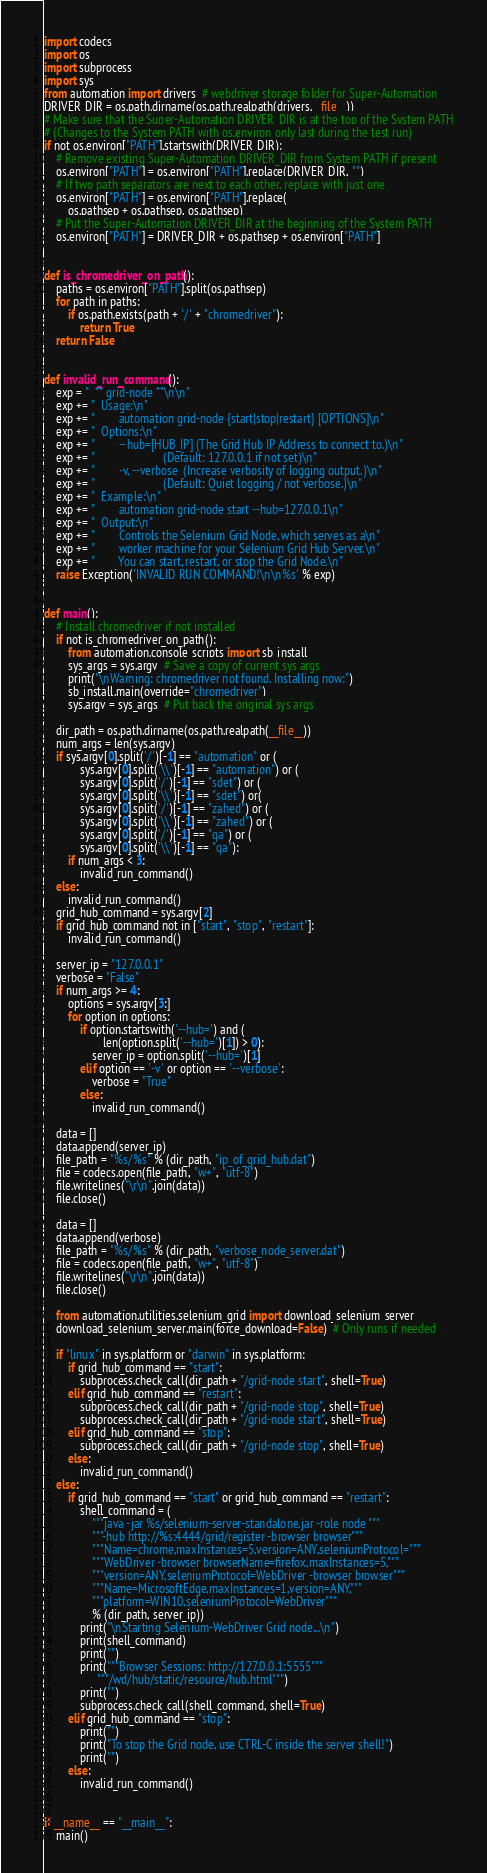Convert code to text. <code><loc_0><loc_0><loc_500><loc_500><_Python_>import codecs
import os
import subprocess
import sys
from automation import drivers  # webdriver storage folder for Super-Automation
DRIVER_DIR = os.path.dirname(os.path.realpath(drivers.__file__))
# Make sure that the Super-Automation DRIVER_DIR is at the top of the System PATH
# (Changes to the System PATH with os.environ only last during the test run)
if not os.environ["PATH"].startswith(DRIVER_DIR):
    # Remove existing Super-Automation DRIVER_DIR from System PATH if present
    os.environ["PATH"] = os.environ["PATH"].replace(DRIVER_DIR, "")
    # If two path separators are next to each other, replace with just one
    os.environ["PATH"] = os.environ["PATH"].replace(
        os.pathsep + os.pathsep, os.pathsep)
    # Put the Super-Automation DRIVER_DIR at the beginning of the System PATH
    os.environ["PATH"] = DRIVER_DIR + os.pathsep + os.environ["PATH"]


def is_chromedriver_on_path():
    paths = os.environ["PATH"].split(os.pathsep)
    for path in paths:
        if os.path.exists(path + '/' + "chromedriver"):
            return True
    return False


def invalid_run_command():
    exp = "  ** grid-node **\n\n"
    exp += "  Usage:\n"
    exp += "        automation grid-node {start|stop|restart} [OPTIONS]\n"
    exp += "  Options:\n"
    exp += "        --hub=[HUB_IP] (The Grid Hub IP Address to connect to.)\n"
    exp += "                       (Default: 127.0.0.1 if not set)\n"
    exp += "        -v, --verbose  (Increase verbosity of logging output.)\n"
    exp += "                       (Default: Quiet logging / not verbose.)\n"
    exp += "  Example:\n"
    exp += "        automation grid-node start --hub=127.0.0.1\n"
    exp += "  Output:\n"
    exp += "        Controls the Selenium Grid Node, which serves as a\n"
    exp += "        worker machine for your Selenium Grid Hub Server.\n"
    exp += "        You can start, restart, or stop the Grid Node.\n"
    raise Exception('INVALID RUN COMMAND!\n\n%s' % exp)


def main():
    # Install chromedriver if not installed
    if not is_chromedriver_on_path():
        from automation.console_scripts import sb_install
        sys_args = sys.argv  # Save a copy of current sys args
        print("\nWarning: chromedriver not found. Installing now:")
        sb_install.main(override="chromedriver")
        sys.argv = sys_args  # Put back the original sys args

    dir_path = os.path.dirname(os.path.realpath(__file__))
    num_args = len(sys.argv)
    if sys.argv[0].split('/')[-1] == "automation" or (
            sys.argv[0].split('\\')[-1] == "automation") or (
            sys.argv[0].split('/')[-1] == "sdet") or (
            sys.argv[0].split('\\')[-1] == "sdet") or(
            sys.argv[0].split('/')[-1] == "zahed") or (
            sys.argv[0].split('\\')[-1] == "zahed") or (
            sys.argv[0].split('/')[-1] == "qa") or (
            sys.argv[0].split('\\')[-1] == "qa"):
        if num_args < 3:
            invalid_run_command()
    else:
        invalid_run_command()
    grid_hub_command = sys.argv[2]
    if grid_hub_command not in ["start", "stop", "restart"]:
        invalid_run_command()

    server_ip = "127.0.0.1"
    verbose = "False"
    if num_args >= 4:
        options = sys.argv[3:]
        for option in options:
            if option.startswith('--hub=') and (
                    len(option.split('--hub=')[1]) > 0):
                server_ip = option.split('--hub=')[1]
            elif option == '-v' or option == '--verbose':
                verbose = "True"
            else:
                invalid_run_command()

    data = []
    data.append(server_ip)
    file_path = "%s/%s" % (dir_path, "ip_of_grid_hub.dat")
    file = codecs.open(file_path, "w+", "utf-8")
    file.writelines("\r\n".join(data))
    file.close()

    data = []
    data.append(verbose)
    file_path = "%s/%s" % (dir_path, "verbose_node_server.dat")
    file = codecs.open(file_path, "w+", "utf-8")
    file.writelines("\r\n".join(data))
    file.close()

    from automation.utilities.selenium_grid import download_selenium_server
    download_selenium_server.main(force_download=False)  # Only runs if needed

    if "linux" in sys.platform or "darwin" in sys.platform:
        if grid_hub_command == "start":
            subprocess.check_call(dir_path + "/grid-node start", shell=True)
        elif grid_hub_command == "restart":
            subprocess.check_call(dir_path + "/grid-node stop", shell=True)
            subprocess.check_call(dir_path + "/grid-node start", shell=True)
        elif grid_hub_command == "stop":
            subprocess.check_call(dir_path + "/grid-node stop", shell=True)
        else:
            invalid_run_command()
    else:
        if grid_hub_command == "start" or grid_hub_command == "restart":
            shell_command = (
                """java -jar %s/selenium-server-standalone.jar -role node """
                """-hub http://%s:4444/grid/register -browser browser"""
                """Name=chrome,maxInstances=5,version=ANY,seleniumProtocol="""
                """WebDriver -browser browserName=firefox,maxInstances=5,"""
                """version=ANY,seleniumProtocol=WebDriver -browser browser"""
                """Name=MicrosoftEdge,maxInstances=1,version=ANY,"""
                """platform=WIN10,seleniumProtocol=WebDriver"""
                % (dir_path, server_ip))
            print("\nStarting Selenium-WebDriver Grid node...\n")
            print(shell_command)
            print("")
            print("""Browser Sessions: http://127.0.0.1:5555"""
                  """/wd/hub/static/resource/hub.html""")
            print("")
            subprocess.check_call(shell_command, shell=True)
        elif grid_hub_command == "stop":
            print("")
            print("To stop the Grid node, use CTRL-C inside the server shell!")
            print("")
        else:
            invalid_run_command()


if __name__ == "__main__":
    main()
</code> 